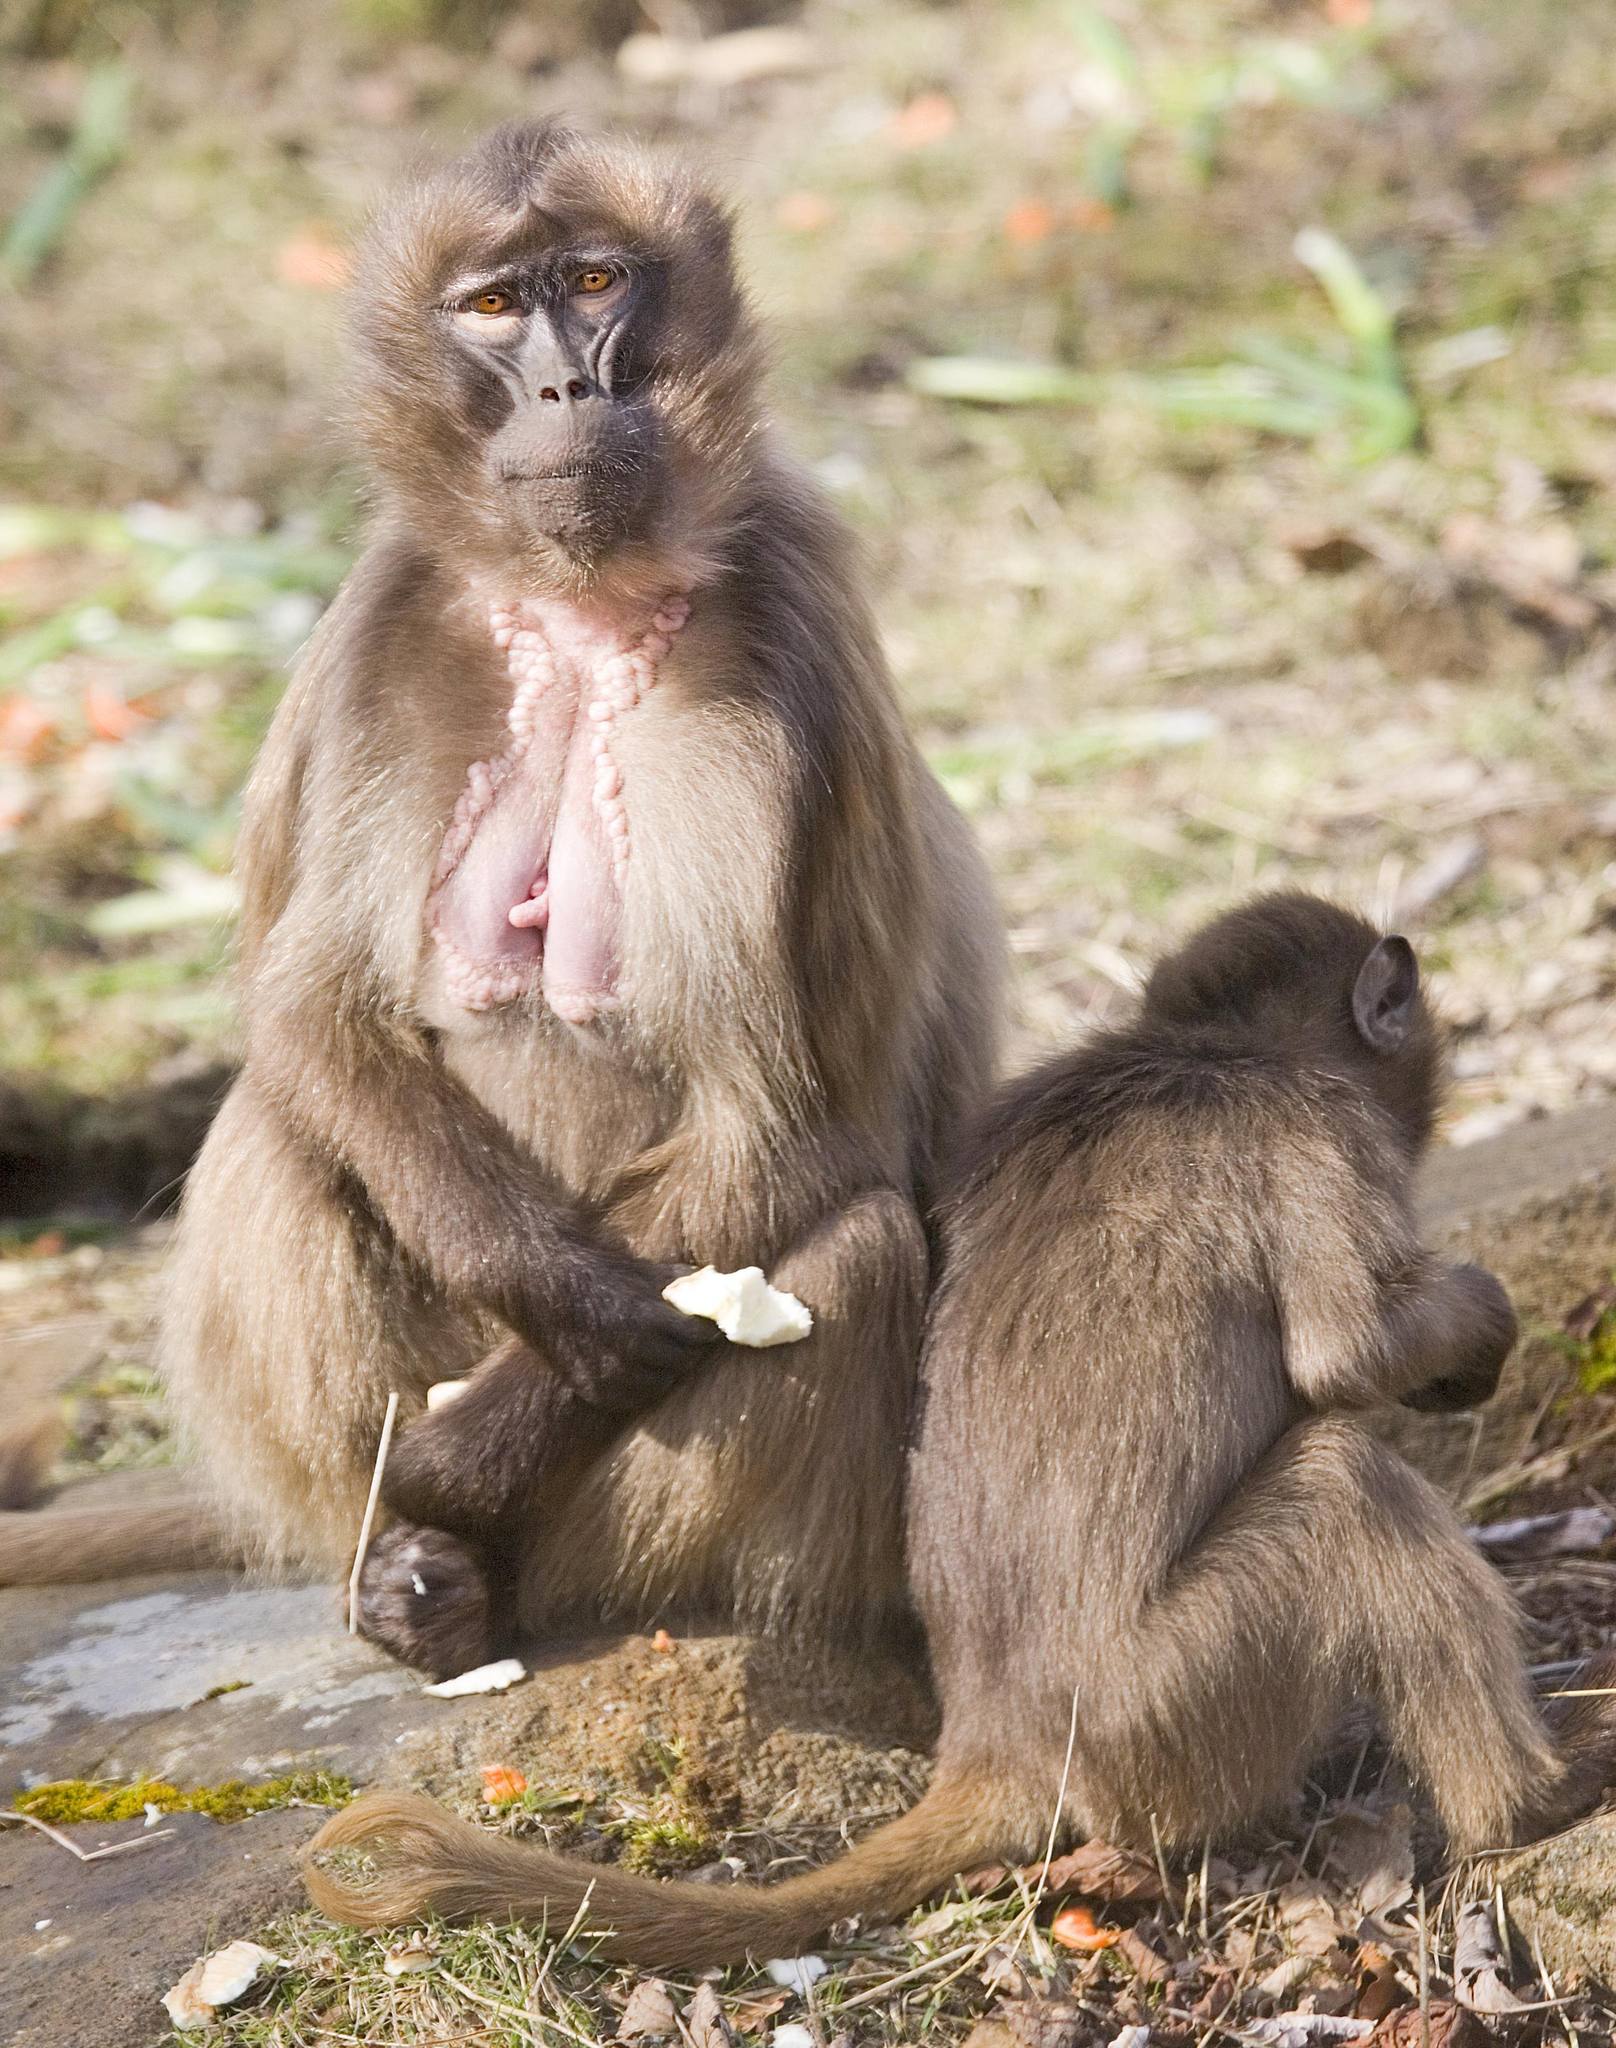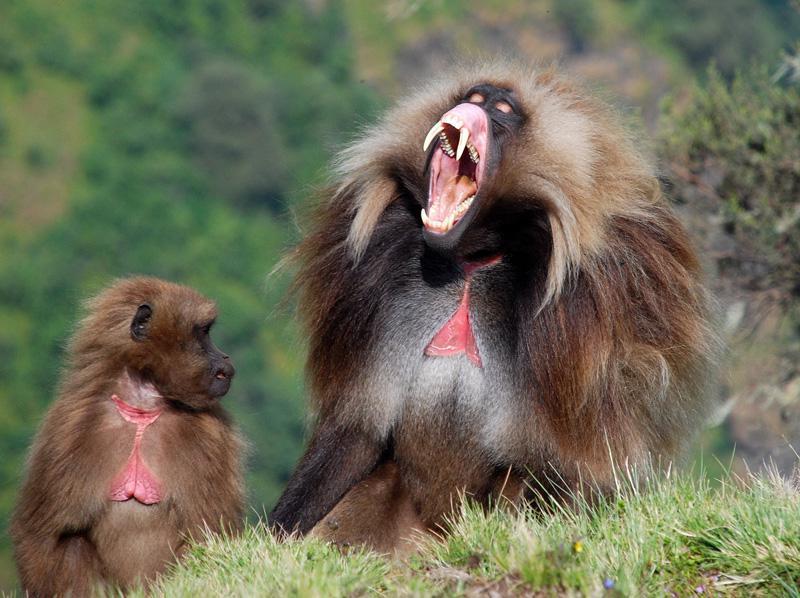The first image is the image on the left, the second image is the image on the right. For the images shown, is this caption "There is exactly one animal baring its teeth in the image on the right." true? Answer yes or no. Yes. The first image is the image on the left, the second image is the image on the right. Examine the images to the left and right. Is the description "A total of four monkeys are shown." accurate? Answer yes or no. Yes. 